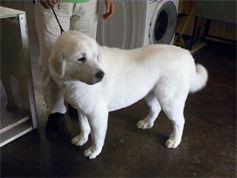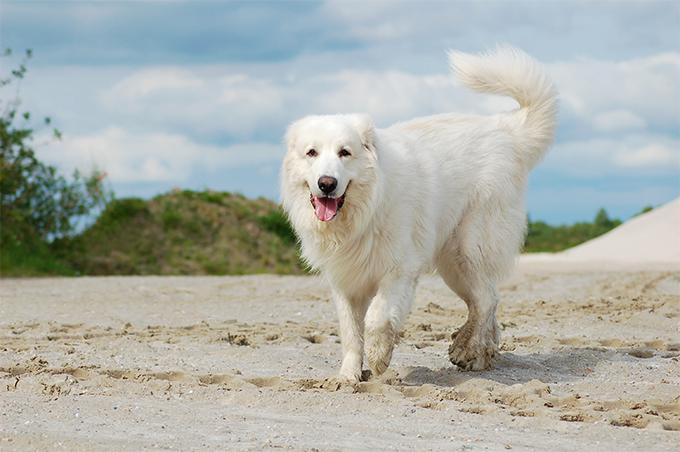The first image is the image on the left, the second image is the image on the right. Analyze the images presented: Is the assertion "A single dog is posing in a grassy area in the image on the left." valid? Answer yes or no. No. 